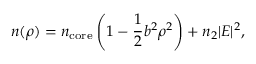Convert formula to latex. <formula><loc_0><loc_0><loc_500><loc_500>n ( \rho ) = n _ { c o r e } \left ( 1 - \frac { 1 } { 2 } b ^ { 2 } \rho ^ { 2 } \right ) + n _ { 2 } | E | ^ { 2 } ,</formula> 